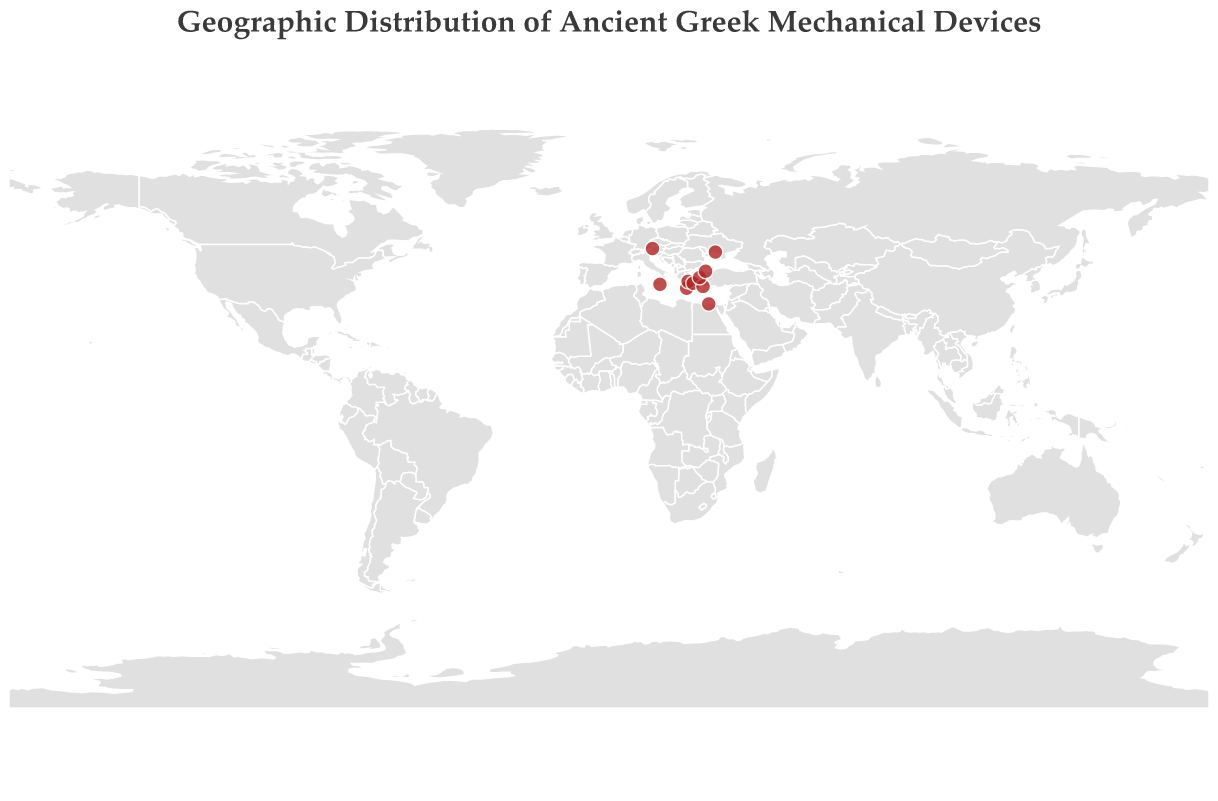How many mechanical devices are marked on the map? Count the number of circles on the map. There are 10 circles, so there are 10 mechanical devices marked on the map.
Answer: 10 Which artifact is located furthest north? Look for the artifact with the highest latitude value. The Salzburg Cube in Salzburg (Austria) is located at a latitude of 47.8095, making it the furthest north.
Answer: Salzburg Cube Are there any artifacts located on the same latitude as Antikythera Island? Check if any other artifacts have the same latitude value of 35.8833. No other artifacts share this latitude.
Answer: No What is the average latitude for all the artifacts? Add all latitude values (35.8833 + 46.7500 + 37.9742 + 47.8095 + 37.0667 + 31.1981 + 37.3964 + 36.4344 + 39.1318 + 41.0082) and divide by the number of artifacts (10). Sum is 391.6526, so the average latitude is 391.6526/10 = 39.1653.
Answer: 39.1653 Which artifact is found at the closest distance to Athens? Calculate the distance between Athens (37.9742, 23.7267) and each other artifact's coordinates. The Antikythera Mechanism is closest to Athens.
Answer: Antikythera Mechanism What is the median longitude of the artifacts? List the longitudes in ascending order (13.0550, 15.2833, 23.3000, 23.7267, 25.2674, 27.1844, 28.2176, 28.9784, 29.9192, 31.9167). The median is the average of the 5th and 6th values, so (25.2674 + 27.1844)/2 = 26.2259.
Answer: 26.2259 Which artifact is located in Syracuse? Match the location name "Syracuse" from the tooltip information with the artifact name. The artifact located in Syracuse is Archimedes Planetarium.
Answer: Archimedes Planetarium What continent has the highest number of identified artifacts? Group the artifacts by continent (Europe, Asia, Africa). Europe has a total of 7 artifacts, Asia has 1, and Africa has 1. Europe has the highest number of identified artifacts.
Answer: Europe 